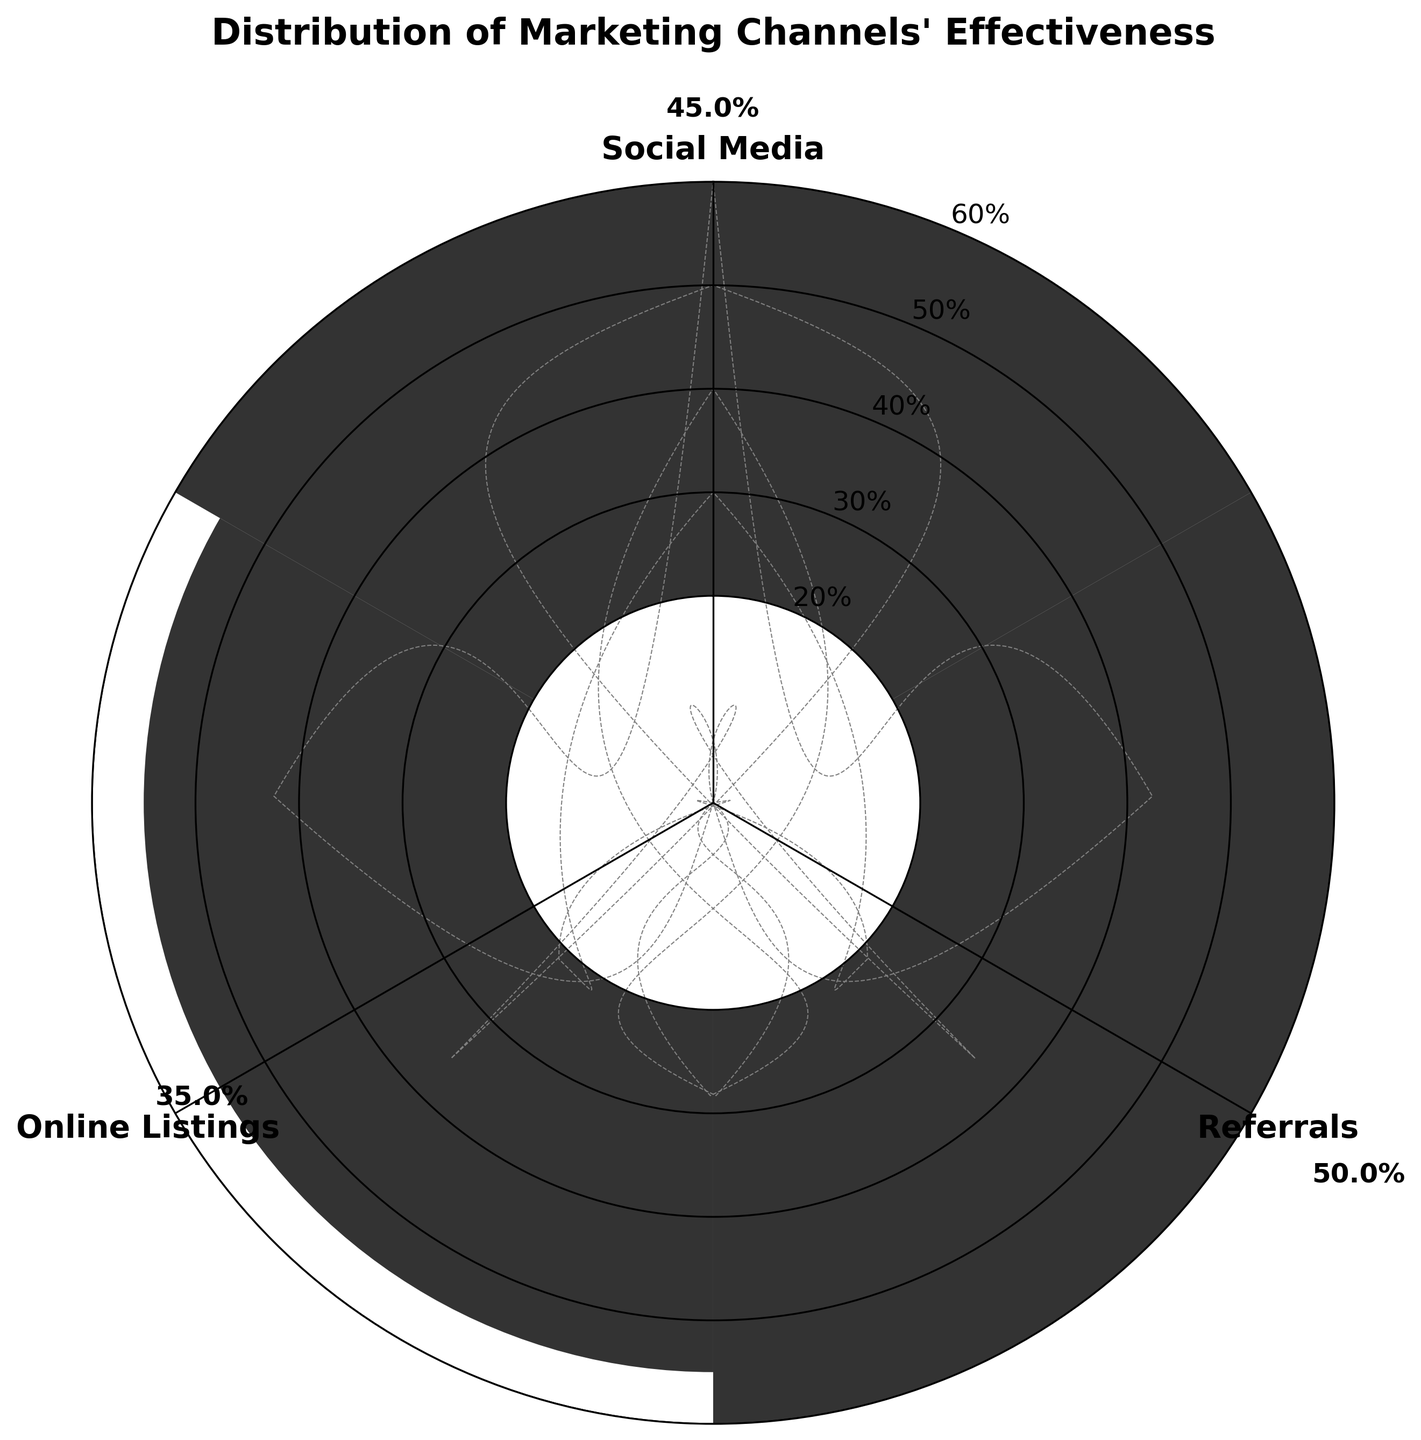What is the title of the chart? The title is usually located at the top of the chart and provides a summary of what the chart represents. In this case, it is clearly written at the top.
Answer: Distribution of Marketing Channels' Effectiveness How many marketing channels are shown? By observing the number of segmented groups in the rose chart, each labeled with a different marketing channel, we can count them.
Answer: 3 What is the average effectiveness for Social Media? Refer to the value labels plotted along the axis for Social Media and directly read the numeric value. The chart shows the average effectiveness.
Answer: 35% Which marketing channel shows the highest effectiveness? Compare the numerical values labeled at the top of each segment. Identify the largest value, which represents the highest effectiveness.
Answer: Referrals What is the difference in effectiveness between Referrals and Online Listings? Look at the labeled values for Referrals and Online Listings. Calculate the difference between these two values (50% - 45%).
Answer: 5% What is the range of effectiveness values depicted in the chart? The range can be found by identifying the minimum and maximum values shown on the polar bars for all marketing channels. (The minimum is 35%, and the maximum is 55%).
Answer: 20% How does Social Media's effectiveness compare to Online Listings? Compare the labeled value for Social Media with that of Online Listings to see which one is greater or lesser.
Answer: Social Media is less effective If we sum the effectiveness percentages of all channels, what is the total? Add up the average effectiveness percentages of Social Media (35%), Referrals (50%), and Online Listings (45%). (35% + 50% + 45% = 130%).
Answer: 130% Which marketing channel has the most consistent effectiveness across different entries? By analyzing the size and placement of the segments in the chart, we can infer the consistency of each channel's effectiveness. If a channel has bars clumped closer in size, it indicates consistency.
Answer: Social Media What additional insights can be drawn about the marketing channels' effectiveness distribution? Look at the overall spread and distribution of the effectiveness values for the channels. The insights include variability (e.g., values ranging from 30-55%) and general trends like which channel tends to perform better.
Answer: Referrals generally have higher effectiveness with less variability 